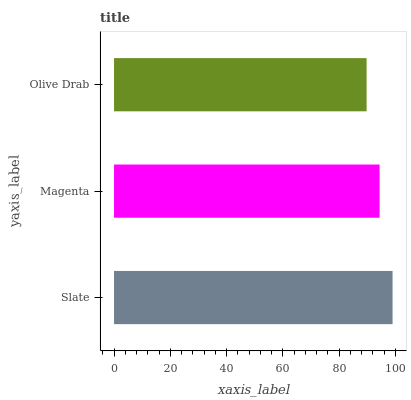Is Olive Drab the minimum?
Answer yes or no. Yes. Is Slate the maximum?
Answer yes or no. Yes. Is Magenta the minimum?
Answer yes or no. No. Is Magenta the maximum?
Answer yes or no. No. Is Slate greater than Magenta?
Answer yes or no. Yes. Is Magenta less than Slate?
Answer yes or no. Yes. Is Magenta greater than Slate?
Answer yes or no. No. Is Slate less than Magenta?
Answer yes or no. No. Is Magenta the high median?
Answer yes or no. Yes. Is Magenta the low median?
Answer yes or no. Yes. Is Olive Drab the high median?
Answer yes or no. No. Is Olive Drab the low median?
Answer yes or no. No. 